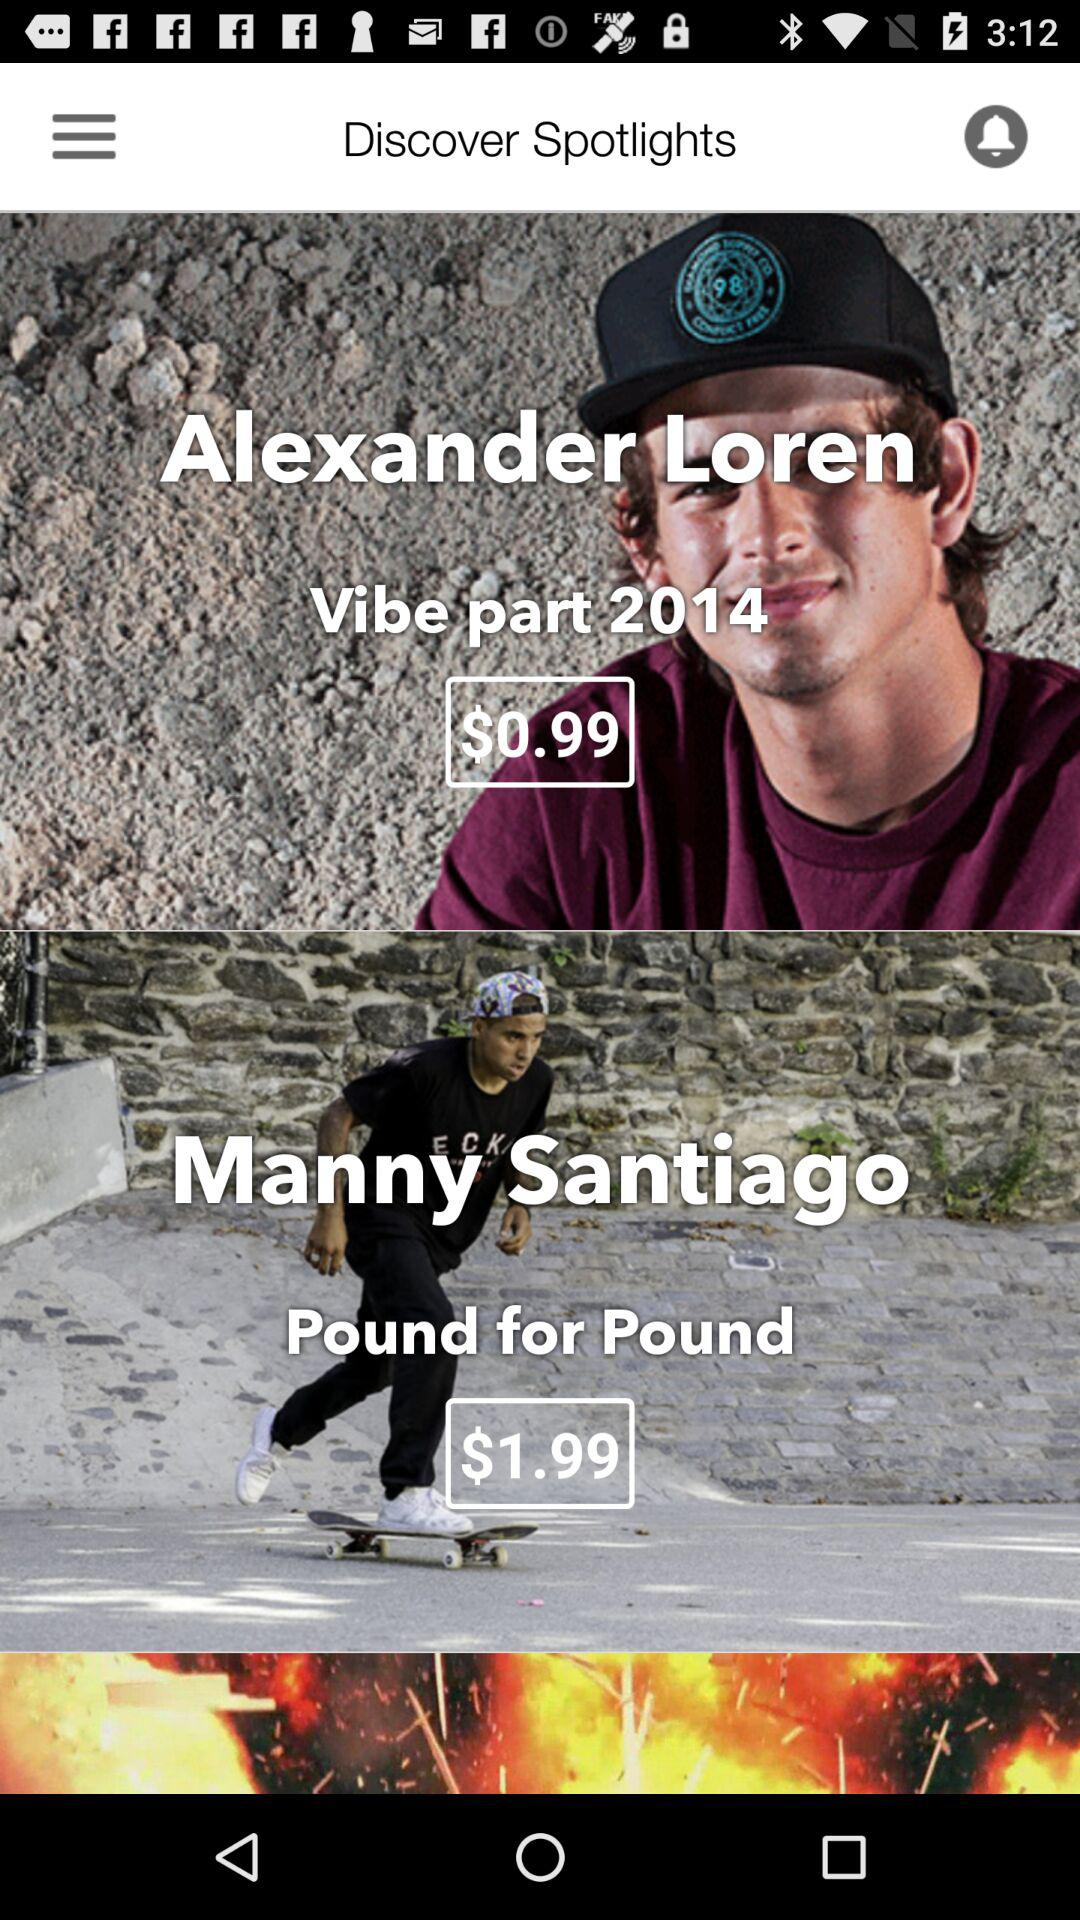What is the price of the "Alexander Loren Vibe part"? The price of the "Alexander Loren Vibe part" is $0.99. 